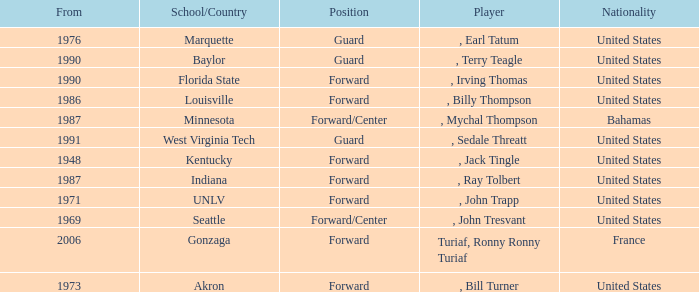What was the nationality of all players from the year 1976? United States. 